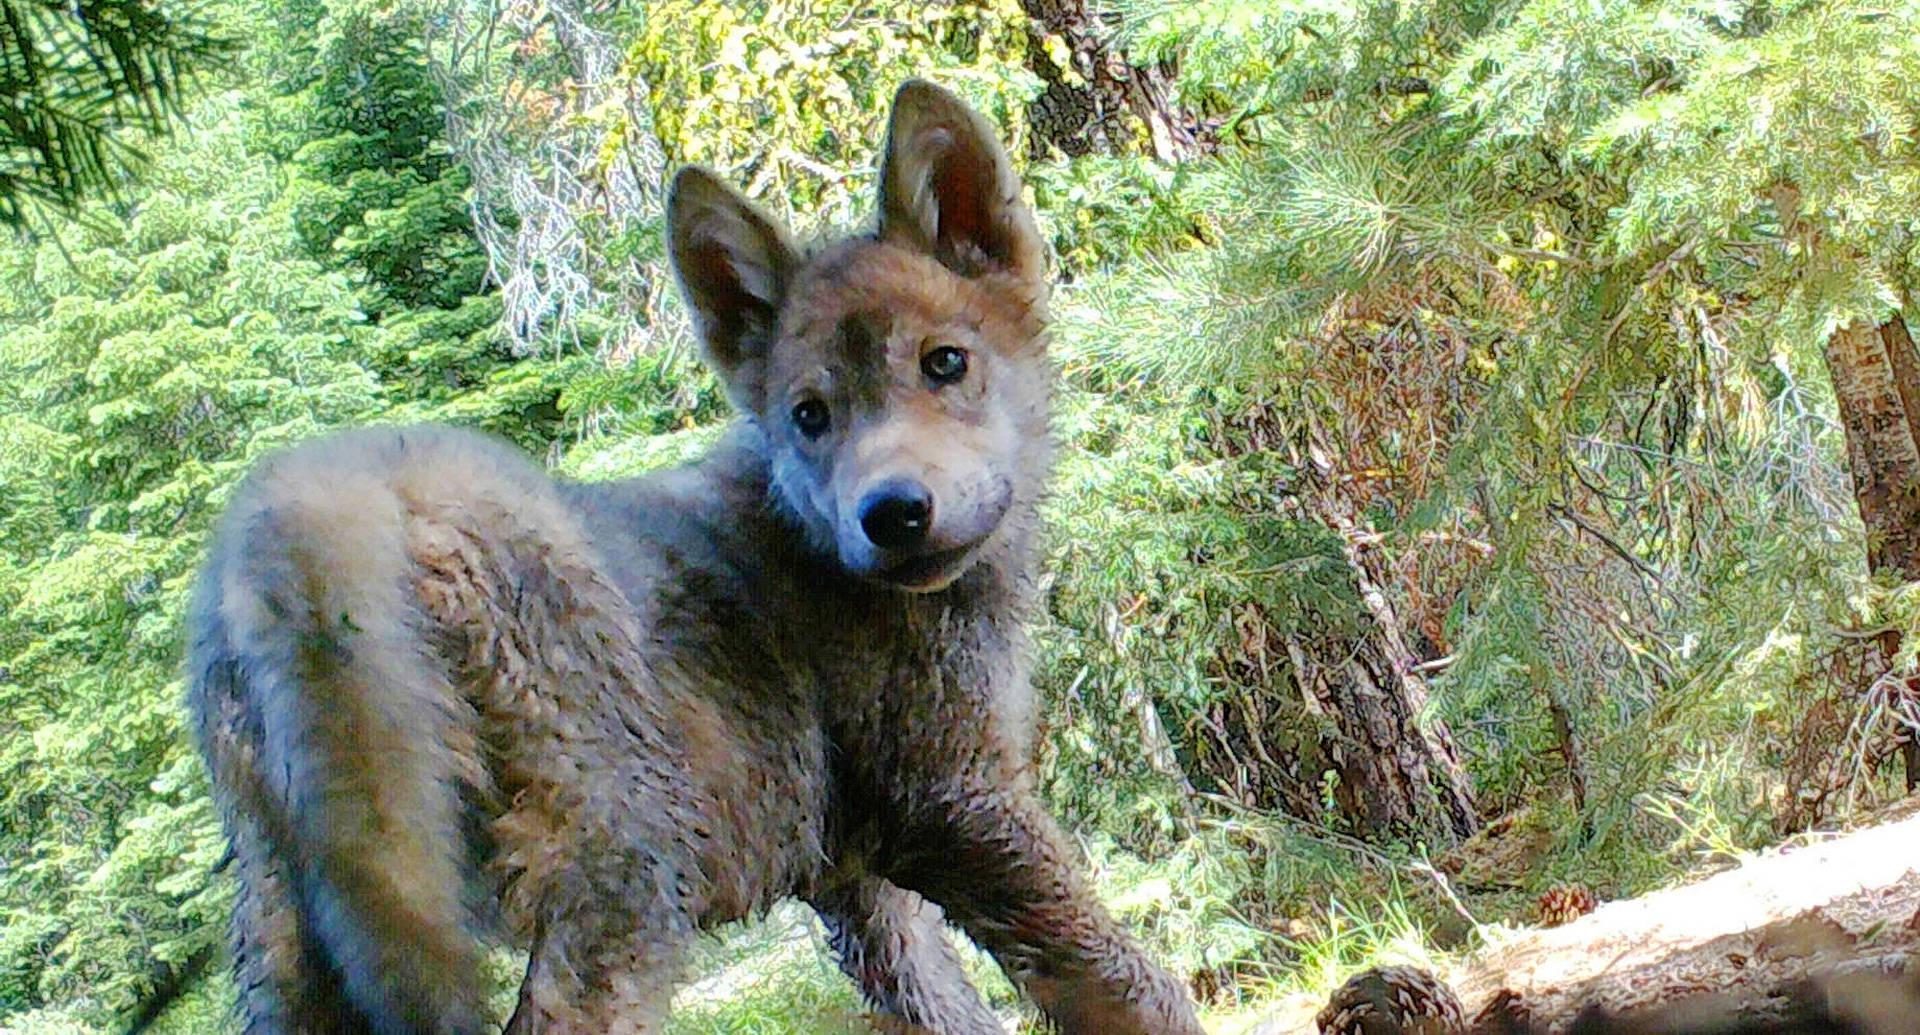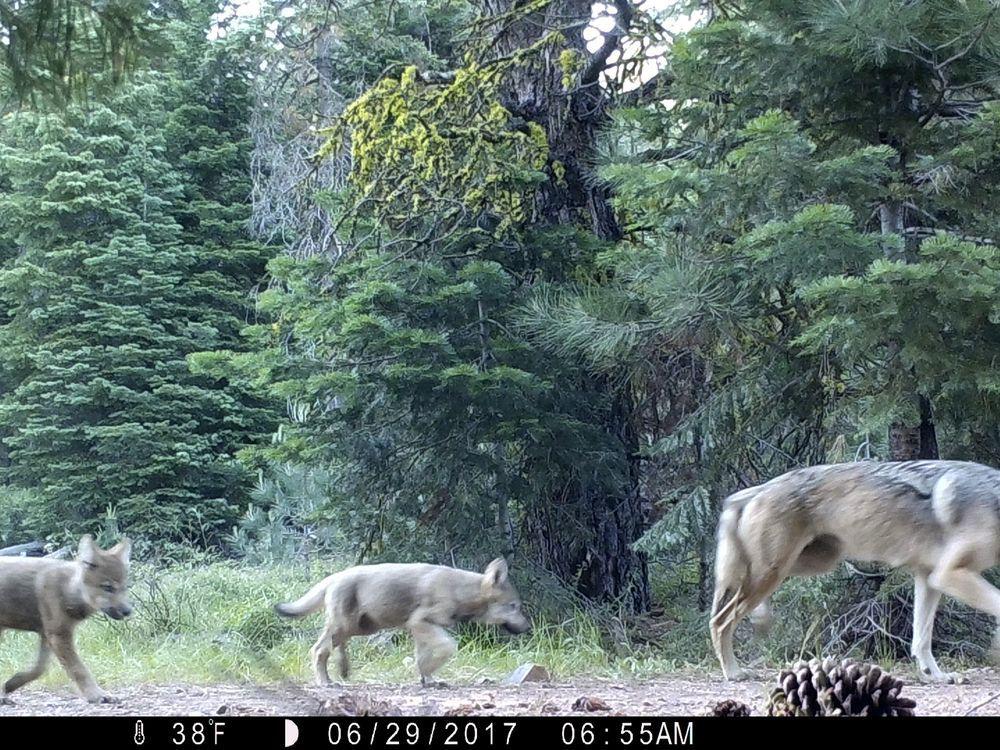The first image is the image on the left, the second image is the image on the right. Examine the images to the left and right. Is the description "There is one dog outside in the image on the right." accurate? Answer yes or no. No. 